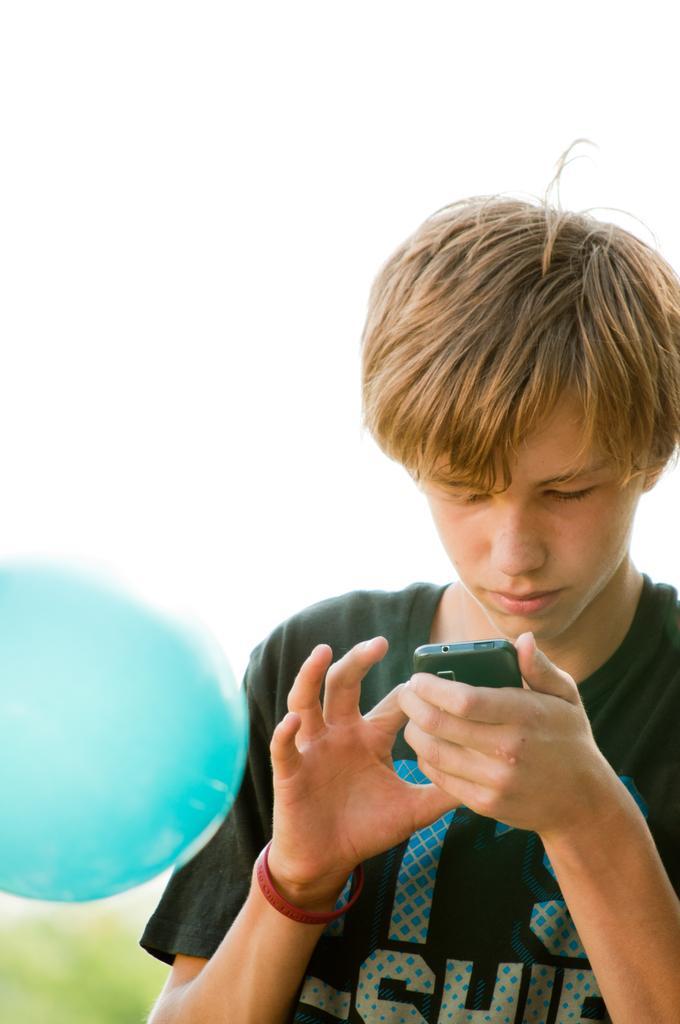Please provide a concise description of this image. In this image I can see a person holding the mobile. 